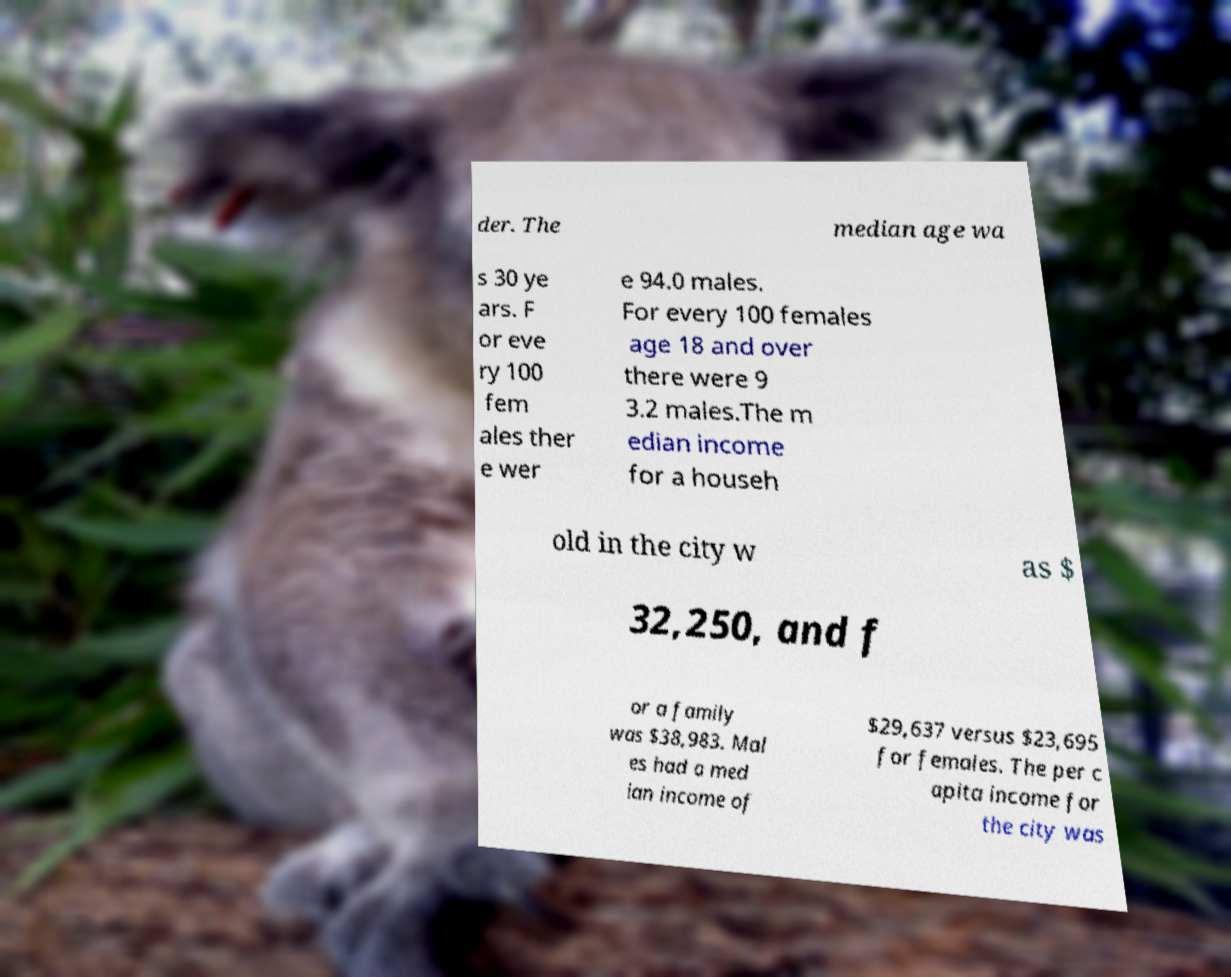Can you read and provide the text displayed in the image?This photo seems to have some interesting text. Can you extract and type it out for me? der. The median age wa s 30 ye ars. F or eve ry 100 fem ales ther e wer e 94.0 males. For every 100 females age 18 and over there were 9 3.2 males.The m edian income for a househ old in the city w as $ 32,250, and f or a family was $38,983. Mal es had a med ian income of $29,637 versus $23,695 for females. The per c apita income for the city was 